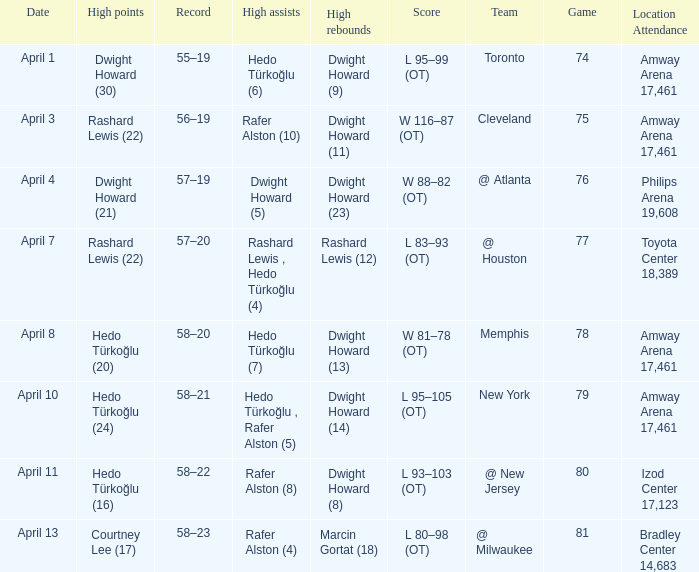What was the score in game 81? L 80–98 (OT). 